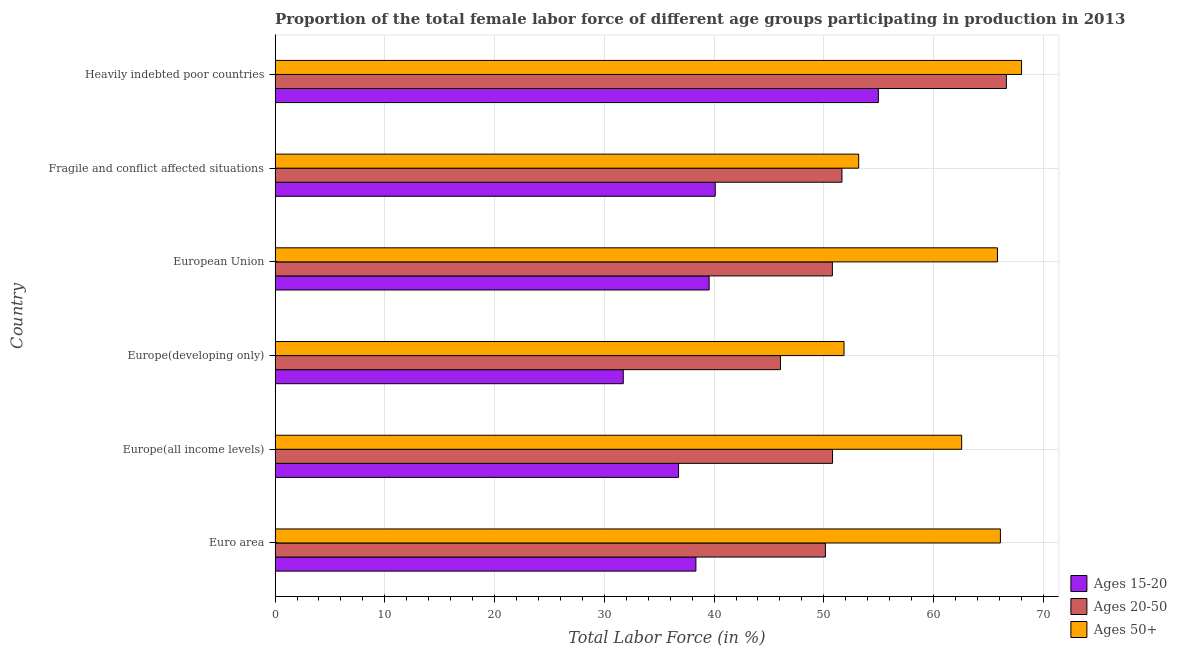Are the number of bars per tick equal to the number of legend labels?
Make the answer very short. Yes. Are the number of bars on each tick of the Y-axis equal?
Ensure brevity in your answer.  Yes. How many bars are there on the 3rd tick from the top?
Offer a very short reply. 3. How many bars are there on the 1st tick from the bottom?
Offer a very short reply. 3. What is the label of the 4th group of bars from the top?
Make the answer very short. Europe(developing only). What is the percentage of female labor force above age 50 in Euro area?
Keep it short and to the point. 66.09. Across all countries, what is the maximum percentage of female labor force above age 50?
Offer a very short reply. 68.02. Across all countries, what is the minimum percentage of female labor force within the age group 15-20?
Offer a very short reply. 31.73. In which country was the percentage of female labor force within the age group 15-20 maximum?
Ensure brevity in your answer.  Heavily indebted poor countries. In which country was the percentage of female labor force within the age group 20-50 minimum?
Make the answer very short. Europe(developing only). What is the total percentage of female labor force within the age group 15-20 in the graph?
Provide a succinct answer. 241.46. What is the difference between the percentage of female labor force within the age group 20-50 in European Union and that in Fragile and conflict affected situations?
Ensure brevity in your answer.  -0.87. What is the difference between the percentage of female labor force within the age group 15-20 in Europe(developing only) and the percentage of female labor force above age 50 in European Union?
Make the answer very short. -34.1. What is the average percentage of female labor force above age 50 per country?
Offer a very short reply. 61.25. What is the difference between the percentage of female labor force within the age group 15-20 and percentage of female labor force above age 50 in Euro area?
Your response must be concise. -27.74. What is the ratio of the percentage of female labor force within the age group 15-20 in Europe(developing only) to that in European Union?
Your answer should be compact. 0.8. What is the difference between the highest and the second highest percentage of female labor force within the age group 15-20?
Your answer should be compact. 14.86. What is the difference between the highest and the lowest percentage of female labor force within the age group 15-20?
Provide a short and direct response. 23.24. What does the 3rd bar from the top in Heavily indebted poor countries represents?
Give a very brief answer. Ages 15-20. What does the 2nd bar from the bottom in European Union represents?
Keep it short and to the point. Ages 20-50. Are all the bars in the graph horizontal?
Offer a very short reply. Yes. What is the difference between two consecutive major ticks on the X-axis?
Keep it short and to the point. 10. Are the values on the major ticks of X-axis written in scientific E-notation?
Make the answer very short. No. Does the graph contain any zero values?
Keep it short and to the point. No. Does the graph contain grids?
Make the answer very short. Yes. How many legend labels are there?
Offer a terse response. 3. How are the legend labels stacked?
Make the answer very short. Vertical. What is the title of the graph?
Your answer should be very brief. Proportion of the total female labor force of different age groups participating in production in 2013. Does "Taxes on income" appear as one of the legend labels in the graph?
Make the answer very short. No. What is the label or title of the X-axis?
Provide a short and direct response. Total Labor Force (in %). What is the Total Labor Force (in %) of Ages 15-20 in Euro area?
Provide a short and direct response. 38.34. What is the Total Labor Force (in %) of Ages 20-50 in Euro area?
Offer a terse response. 50.14. What is the Total Labor Force (in %) in Ages 50+ in Euro area?
Make the answer very short. 66.09. What is the Total Labor Force (in %) of Ages 15-20 in Europe(all income levels)?
Your answer should be compact. 36.76. What is the Total Labor Force (in %) of Ages 20-50 in Europe(all income levels)?
Offer a terse response. 50.79. What is the Total Labor Force (in %) in Ages 50+ in Europe(all income levels)?
Give a very brief answer. 62.56. What is the Total Labor Force (in %) of Ages 15-20 in Europe(developing only)?
Give a very brief answer. 31.73. What is the Total Labor Force (in %) of Ages 20-50 in Europe(developing only)?
Make the answer very short. 46.05. What is the Total Labor Force (in %) in Ages 50+ in Europe(developing only)?
Your response must be concise. 51.84. What is the Total Labor Force (in %) in Ages 15-20 in European Union?
Offer a terse response. 39.55. What is the Total Labor Force (in %) in Ages 20-50 in European Union?
Ensure brevity in your answer.  50.78. What is the Total Labor Force (in %) in Ages 50+ in European Union?
Offer a terse response. 65.82. What is the Total Labor Force (in %) in Ages 15-20 in Fragile and conflict affected situations?
Give a very brief answer. 40.11. What is the Total Labor Force (in %) in Ages 20-50 in Fragile and conflict affected situations?
Your response must be concise. 51.65. What is the Total Labor Force (in %) in Ages 50+ in Fragile and conflict affected situations?
Offer a terse response. 53.18. What is the Total Labor Force (in %) of Ages 15-20 in Heavily indebted poor countries?
Provide a short and direct response. 54.97. What is the Total Labor Force (in %) in Ages 20-50 in Heavily indebted poor countries?
Provide a succinct answer. 66.63. What is the Total Labor Force (in %) of Ages 50+ in Heavily indebted poor countries?
Offer a terse response. 68.02. Across all countries, what is the maximum Total Labor Force (in %) of Ages 15-20?
Give a very brief answer. 54.97. Across all countries, what is the maximum Total Labor Force (in %) of Ages 20-50?
Give a very brief answer. 66.63. Across all countries, what is the maximum Total Labor Force (in %) of Ages 50+?
Your answer should be compact. 68.02. Across all countries, what is the minimum Total Labor Force (in %) in Ages 15-20?
Provide a short and direct response. 31.73. Across all countries, what is the minimum Total Labor Force (in %) in Ages 20-50?
Your answer should be very brief. 46.05. Across all countries, what is the minimum Total Labor Force (in %) in Ages 50+?
Offer a terse response. 51.84. What is the total Total Labor Force (in %) in Ages 15-20 in the graph?
Ensure brevity in your answer.  241.46. What is the total Total Labor Force (in %) of Ages 20-50 in the graph?
Your answer should be compact. 316.05. What is the total Total Labor Force (in %) of Ages 50+ in the graph?
Give a very brief answer. 367.5. What is the difference between the Total Labor Force (in %) in Ages 15-20 in Euro area and that in Europe(all income levels)?
Make the answer very short. 1.58. What is the difference between the Total Labor Force (in %) of Ages 20-50 in Euro area and that in Europe(all income levels)?
Your answer should be very brief. -0.65. What is the difference between the Total Labor Force (in %) of Ages 50+ in Euro area and that in Europe(all income levels)?
Your answer should be very brief. 3.53. What is the difference between the Total Labor Force (in %) of Ages 15-20 in Euro area and that in Europe(developing only)?
Offer a terse response. 6.62. What is the difference between the Total Labor Force (in %) of Ages 20-50 in Euro area and that in Europe(developing only)?
Give a very brief answer. 4.1. What is the difference between the Total Labor Force (in %) in Ages 50+ in Euro area and that in Europe(developing only)?
Your answer should be compact. 14.25. What is the difference between the Total Labor Force (in %) in Ages 15-20 in Euro area and that in European Union?
Provide a short and direct response. -1.21. What is the difference between the Total Labor Force (in %) in Ages 20-50 in Euro area and that in European Union?
Your response must be concise. -0.64. What is the difference between the Total Labor Force (in %) of Ages 50+ in Euro area and that in European Union?
Offer a terse response. 0.27. What is the difference between the Total Labor Force (in %) of Ages 15-20 in Euro area and that in Fragile and conflict affected situations?
Provide a succinct answer. -1.76. What is the difference between the Total Labor Force (in %) in Ages 20-50 in Euro area and that in Fragile and conflict affected situations?
Keep it short and to the point. -1.51. What is the difference between the Total Labor Force (in %) in Ages 50+ in Euro area and that in Fragile and conflict affected situations?
Offer a very short reply. 12.91. What is the difference between the Total Labor Force (in %) in Ages 15-20 in Euro area and that in Heavily indebted poor countries?
Your response must be concise. -16.62. What is the difference between the Total Labor Force (in %) of Ages 20-50 in Euro area and that in Heavily indebted poor countries?
Ensure brevity in your answer.  -16.49. What is the difference between the Total Labor Force (in %) of Ages 50+ in Euro area and that in Heavily indebted poor countries?
Ensure brevity in your answer.  -1.93. What is the difference between the Total Labor Force (in %) of Ages 15-20 in Europe(all income levels) and that in Europe(developing only)?
Your answer should be compact. 5.04. What is the difference between the Total Labor Force (in %) in Ages 20-50 in Europe(all income levels) and that in Europe(developing only)?
Ensure brevity in your answer.  4.75. What is the difference between the Total Labor Force (in %) in Ages 50+ in Europe(all income levels) and that in Europe(developing only)?
Ensure brevity in your answer.  10.72. What is the difference between the Total Labor Force (in %) in Ages 15-20 in Europe(all income levels) and that in European Union?
Provide a succinct answer. -2.79. What is the difference between the Total Labor Force (in %) of Ages 20-50 in Europe(all income levels) and that in European Union?
Offer a very short reply. 0.01. What is the difference between the Total Labor Force (in %) of Ages 50+ in Europe(all income levels) and that in European Union?
Ensure brevity in your answer.  -3.26. What is the difference between the Total Labor Force (in %) of Ages 15-20 in Europe(all income levels) and that in Fragile and conflict affected situations?
Make the answer very short. -3.34. What is the difference between the Total Labor Force (in %) in Ages 20-50 in Europe(all income levels) and that in Fragile and conflict affected situations?
Your response must be concise. -0.86. What is the difference between the Total Labor Force (in %) in Ages 50+ in Europe(all income levels) and that in Fragile and conflict affected situations?
Your answer should be very brief. 9.38. What is the difference between the Total Labor Force (in %) of Ages 15-20 in Europe(all income levels) and that in Heavily indebted poor countries?
Provide a succinct answer. -18.21. What is the difference between the Total Labor Force (in %) of Ages 20-50 in Europe(all income levels) and that in Heavily indebted poor countries?
Provide a short and direct response. -15.84. What is the difference between the Total Labor Force (in %) in Ages 50+ in Europe(all income levels) and that in Heavily indebted poor countries?
Make the answer very short. -5.46. What is the difference between the Total Labor Force (in %) of Ages 15-20 in Europe(developing only) and that in European Union?
Offer a very short reply. -7.82. What is the difference between the Total Labor Force (in %) of Ages 20-50 in Europe(developing only) and that in European Union?
Offer a very short reply. -4.73. What is the difference between the Total Labor Force (in %) in Ages 50+ in Europe(developing only) and that in European Union?
Keep it short and to the point. -13.98. What is the difference between the Total Labor Force (in %) in Ages 15-20 in Europe(developing only) and that in Fragile and conflict affected situations?
Keep it short and to the point. -8.38. What is the difference between the Total Labor Force (in %) of Ages 20-50 in Europe(developing only) and that in Fragile and conflict affected situations?
Ensure brevity in your answer.  -5.61. What is the difference between the Total Labor Force (in %) in Ages 50+ in Europe(developing only) and that in Fragile and conflict affected situations?
Give a very brief answer. -1.33. What is the difference between the Total Labor Force (in %) in Ages 15-20 in Europe(developing only) and that in Heavily indebted poor countries?
Offer a terse response. -23.24. What is the difference between the Total Labor Force (in %) in Ages 20-50 in Europe(developing only) and that in Heavily indebted poor countries?
Give a very brief answer. -20.59. What is the difference between the Total Labor Force (in %) of Ages 50+ in Europe(developing only) and that in Heavily indebted poor countries?
Keep it short and to the point. -16.18. What is the difference between the Total Labor Force (in %) in Ages 15-20 in European Union and that in Fragile and conflict affected situations?
Provide a short and direct response. -0.56. What is the difference between the Total Labor Force (in %) in Ages 20-50 in European Union and that in Fragile and conflict affected situations?
Your response must be concise. -0.87. What is the difference between the Total Labor Force (in %) in Ages 50+ in European Union and that in Fragile and conflict affected situations?
Keep it short and to the point. 12.64. What is the difference between the Total Labor Force (in %) in Ages 15-20 in European Union and that in Heavily indebted poor countries?
Offer a very short reply. -15.42. What is the difference between the Total Labor Force (in %) of Ages 20-50 in European Union and that in Heavily indebted poor countries?
Ensure brevity in your answer.  -15.86. What is the difference between the Total Labor Force (in %) in Ages 50+ in European Union and that in Heavily indebted poor countries?
Ensure brevity in your answer.  -2.2. What is the difference between the Total Labor Force (in %) of Ages 15-20 in Fragile and conflict affected situations and that in Heavily indebted poor countries?
Offer a terse response. -14.86. What is the difference between the Total Labor Force (in %) in Ages 20-50 in Fragile and conflict affected situations and that in Heavily indebted poor countries?
Offer a terse response. -14.98. What is the difference between the Total Labor Force (in %) in Ages 50+ in Fragile and conflict affected situations and that in Heavily indebted poor countries?
Offer a terse response. -14.84. What is the difference between the Total Labor Force (in %) of Ages 15-20 in Euro area and the Total Labor Force (in %) of Ages 20-50 in Europe(all income levels)?
Your answer should be compact. -12.45. What is the difference between the Total Labor Force (in %) of Ages 15-20 in Euro area and the Total Labor Force (in %) of Ages 50+ in Europe(all income levels)?
Offer a very short reply. -24.22. What is the difference between the Total Labor Force (in %) of Ages 20-50 in Euro area and the Total Labor Force (in %) of Ages 50+ in Europe(all income levels)?
Give a very brief answer. -12.42. What is the difference between the Total Labor Force (in %) of Ages 15-20 in Euro area and the Total Labor Force (in %) of Ages 20-50 in Europe(developing only)?
Give a very brief answer. -7.7. What is the difference between the Total Labor Force (in %) of Ages 15-20 in Euro area and the Total Labor Force (in %) of Ages 50+ in Europe(developing only)?
Keep it short and to the point. -13.5. What is the difference between the Total Labor Force (in %) in Ages 20-50 in Euro area and the Total Labor Force (in %) in Ages 50+ in Europe(developing only)?
Give a very brief answer. -1.7. What is the difference between the Total Labor Force (in %) in Ages 15-20 in Euro area and the Total Labor Force (in %) in Ages 20-50 in European Union?
Keep it short and to the point. -12.43. What is the difference between the Total Labor Force (in %) of Ages 15-20 in Euro area and the Total Labor Force (in %) of Ages 50+ in European Union?
Offer a terse response. -27.48. What is the difference between the Total Labor Force (in %) of Ages 20-50 in Euro area and the Total Labor Force (in %) of Ages 50+ in European Union?
Give a very brief answer. -15.68. What is the difference between the Total Labor Force (in %) in Ages 15-20 in Euro area and the Total Labor Force (in %) in Ages 20-50 in Fragile and conflict affected situations?
Keep it short and to the point. -13.31. What is the difference between the Total Labor Force (in %) of Ages 15-20 in Euro area and the Total Labor Force (in %) of Ages 50+ in Fragile and conflict affected situations?
Your answer should be very brief. -14.83. What is the difference between the Total Labor Force (in %) of Ages 20-50 in Euro area and the Total Labor Force (in %) of Ages 50+ in Fragile and conflict affected situations?
Ensure brevity in your answer.  -3.03. What is the difference between the Total Labor Force (in %) of Ages 15-20 in Euro area and the Total Labor Force (in %) of Ages 20-50 in Heavily indebted poor countries?
Provide a short and direct response. -28.29. What is the difference between the Total Labor Force (in %) in Ages 15-20 in Euro area and the Total Labor Force (in %) in Ages 50+ in Heavily indebted poor countries?
Keep it short and to the point. -29.67. What is the difference between the Total Labor Force (in %) in Ages 20-50 in Euro area and the Total Labor Force (in %) in Ages 50+ in Heavily indebted poor countries?
Give a very brief answer. -17.87. What is the difference between the Total Labor Force (in %) of Ages 15-20 in Europe(all income levels) and the Total Labor Force (in %) of Ages 20-50 in Europe(developing only)?
Offer a terse response. -9.28. What is the difference between the Total Labor Force (in %) in Ages 15-20 in Europe(all income levels) and the Total Labor Force (in %) in Ages 50+ in Europe(developing only)?
Keep it short and to the point. -15.08. What is the difference between the Total Labor Force (in %) of Ages 20-50 in Europe(all income levels) and the Total Labor Force (in %) of Ages 50+ in Europe(developing only)?
Offer a terse response. -1.05. What is the difference between the Total Labor Force (in %) in Ages 15-20 in Europe(all income levels) and the Total Labor Force (in %) in Ages 20-50 in European Union?
Offer a terse response. -14.02. What is the difference between the Total Labor Force (in %) of Ages 15-20 in Europe(all income levels) and the Total Labor Force (in %) of Ages 50+ in European Union?
Offer a terse response. -29.06. What is the difference between the Total Labor Force (in %) of Ages 20-50 in Europe(all income levels) and the Total Labor Force (in %) of Ages 50+ in European Union?
Ensure brevity in your answer.  -15.03. What is the difference between the Total Labor Force (in %) in Ages 15-20 in Europe(all income levels) and the Total Labor Force (in %) in Ages 20-50 in Fragile and conflict affected situations?
Your answer should be compact. -14.89. What is the difference between the Total Labor Force (in %) in Ages 15-20 in Europe(all income levels) and the Total Labor Force (in %) in Ages 50+ in Fragile and conflict affected situations?
Provide a succinct answer. -16.41. What is the difference between the Total Labor Force (in %) of Ages 20-50 in Europe(all income levels) and the Total Labor Force (in %) of Ages 50+ in Fragile and conflict affected situations?
Your answer should be very brief. -2.38. What is the difference between the Total Labor Force (in %) in Ages 15-20 in Europe(all income levels) and the Total Labor Force (in %) in Ages 20-50 in Heavily indebted poor countries?
Make the answer very short. -29.87. What is the difference between the Total Labor Force (in %) of Ages 15-20 in Europe(all income levels) and the Total Labor Force (in %) of Ages 50+ in Heavily indebted poor countries?
Ensure brevity in your answer.  -31.25. What is the difference between the Total Labor Force (in %) of Ages 20-50 in Europe(all income levels) and the Total Labor Force (in %) of Ages 50+ in Heavily indebted poor countries?
Give a very brief answer. -17.22. What is the difference between the Total Labor Force (in %) in Ages 15-20 in Europe(developing only) and the Total Labor Force (in %) in Ages 20-50 in European Union?
Keep it short and to the point. -19.05. What is the difference between the Total Labor Force (in %) of Ages 15-20 in Europe(developing only) and the Total Labor Force (in %) of Ages 50+ in European Union?
Provide a succinct answer. -34.1. What is the difference between the Total Labor Force (in %) in Ages 20-50 in Europe(developing only) and the Total Labor Force (in %) in Ages 50+ in European Union?
Your answer should be very brief. -19.77. What is the difference between the Total Labor Force (in %) of Ages 15-20 in Europe(developing only) and the Total Labor Force (in %) of Ages 20-50 in Fragile and conflict affected situations?
Give a very brief answer. -19.93. What is the difference between the Total Labor Force (in %) of Ages 15-20 in Europe(developing only) and the Total Labor Force (in %) of Ages 50+ in Fragile and conflict affected situations?
Your answer should be compact. -21.45. What is the difference between the Total Labor Force (in %) of Ages 20-50 in Europe(developing only) and the Total Labor Force (in %) of Ages 50+ in Fragile and conflict affected situations?
Your answer should be very brief. -7.13. What is the difference between the Total Labor Force (in %) of Ages 15-20 in Europe(developing only) and the Total Labor Force (in %) of Ages 20-50 in Heavily indebted poor countries?
Make the answer very short. -34.91. What is the difference between the Total Labor Force (in %) in Ages 15-20 in Europe(developing only) and the Total Labor Force (in %) in Ages 50+ in Heavily indebted poor countries?
Your answer should be very brief. -36.29. What is the difference between the Total Labor Force (in %) of Ages 20-50 in Europe(developing only) and the Total Labor Force (in %) of Ages 50+ in Heavily indebted poor countries?
Offer a terse response. -21.97. What is the difference between the Total Labor Force (in %) of Ages 15-20 in European Union and the Total Labor Force (in %) of Ages 20-50 in Fragile and conflict affected situations?
Provide a short and direct response. -12.1. What is the difference between the Total Labor Force (in %) in Ages 15-20 in European Union and the Total Labor Force (in %) in Ages 50+ in Fragile and conflict affected situations?
Offer a very short reply. -13.63. What is the difference between the Total Labor Force (in %) in Ages 20-50 in European Union and the Total Labor Force (in %) in Ages 50+ in Fragile and conflict affected situations?
Your answer should be compact. -2.4. What is the difference between the Total Labor Force (in %) of Ages 15-20 in European Union and the Total Labor Force (in %) of Ages 20-50 in Heavily indebted poor countries?
Provide a succinct answer. -27.09. What is the difference between the Total Labor Force (in %) in Ages 15-20 in European Union and the Total Labor Force (in %) in Ages 50+ in Heavily indebted poor countries?
Keep it short and to the point. -28.47. What is the difference between the Total Labor Force (in %) of Ages 20-50 in European Union and the Total Labor Force (in %) of Ages 50+ in Heavily indebted poor countries?
Offer a terse response. -17.24. What is the difference between the Total Labor Force (in %) of Ages 15-20 in Fragile and conflict affected situations and the Total Labor Force (in %) of Ages 20-50 in Heavily indebted poor countries?
Make the answer very short. -26.53. What is the difference between the Total Labor Force (in %) in Ages 15-20 in Fragile and conflict affected situations and the Total Labor Force (in %) in Ages 50+ in Heavily indebted poor countries?
Your answer should be very brief. -27.91. What is the difference between the Total Labor Force (in %) in Ages 20-50 in Fragile and conflict affected situations and the Total Labor Force (in %) in Ages 50+ in Heavily indebted poor countries?
Keep it short and to the point. -16.36. What is the average Total Labor Force (in %) of Ages 15-20 per country?
Provide a short and direct response. 40.24. What is the average Total Labor Force (in %) in Ages 20-50 per country?
Provide a short and direct response. 52.68. What is the average Total Labor Force (in %) in Ages 50+ per country?
Your answer should be compact. 61.25. What is the difference between the Total Labor Force (in %) of Ages 15-20 and Total Labor Force (in %) of Ages 20-50 in Euro area?
Offer a very short reply. -11.8. What is the difference between the Total Labor Force (in %) of Ages 15-20 and Total Labor Force (in %) of Ages 50+ in Euro area?
Your answer should be compact. -27.74. What is the difference between the Total Labor Force (in %) of Ages 20-50 and Total Labor Force (in %) of Ages 50+ in Euro area?
Offer a very short reply. -15.94. What is the difference between the Total Labor Force (in %) of Ages 15-20 and Total Labor Force (in %) of Ages 20-50 in Europe(all income levels)?
Keep it short and to the point. -14.03. What is the difference between the Total Labor Force (in %) in Ages 15-20 and Total Labor Force (in %) in Ages 50+ in Europe(all income levels)?
Your answer should be very brief. -25.8. What is the difference between the Total Labor Force (in %) in Ages 20-50 and Total Labor Force (in %) in Ages 50+ in Europe(all income levels)?
Provide a short and direct response. -11.77. What is the difference between the Total Labor Force (in %) of Ages 15-20 and Total Labor Force (in %) of Ages 20-50 in Europe(developing only)?
Make the answer very short. -14.32. What is the difference between the Total Labor Force (in %) of Ages 15-20 and Total Labor Force (in %) of Ages 50+ in Europe(developing only)?
Your answer should be compact. -20.12. What is the difference between the Total Labor Force (in %) of Ages 20-50 and Total Labor Force (in %) of Ages 50+ in Europe(developing only)?
Ensure brevity in your answer.  -5.79. What is the difference between the Total Labor Force (in %) of Ages 15-20 and Total Labor Force (in %) of Ages 20-50 in European Union?
Your answer should be compact. -11.23. What is the difference between the Total Labor Force (in %) of Ages 15-20 and Total Labor Force (in %) of Ages 50+ in European Union?
Keep it short and to the point. -26.27. What is the difference between the Total Labor Force (in %) of Ages 20-50 and Total Labor Force (in %) of Ages 50+ in European Union?
Provide a short and direct response. -15.04. What is the difference between the Total Labor Force (in %) of Ages 15-20 and Total Labor Force (in %) of Ages 20-50 in Fragile and conflict affected situations?
Your response must be concise. -11.55. What is the difference between the Total Labor Force (in %) in Ages 15-20 and Total Labor Force (in %) in Ages 50+ in Fragile and conflict affected situations?
Provide a short and direct response. -13.07. What is the difference between the Total Labor Force (in %) in Ages 20-50 and Total Labor Force (in %) in Ages 50+ in Fragile and conflict affected situations?
Provide a short and direct response. -1.52. What is the difference between the Total Labor Force (in %) of Ages 15-20 and Total Labor Force (in %) of Ages 20-50 in Heavily indebted poor countries?
Your answer should be compact. -11.67. What is the difference between the Total Labor Force (in %) of Ages 15-20 and Total Labor Force (in %) of Ages 50+ in Heavily indebted poor countries?
Make the answer very short. -13.05. What is the difference between the Total Labor Force (in %) of Ages 20-50 and Total Labor Force (in %) of Ages 50+ in Heavily indebted poor countries?
Your response must be concise. -1.38. What is the ratio of the Total Labor Force (in %) in Ages 15-20 in Euro area to that in Europe(all income levels)?
Your answer should be very brief. 1.04. What is the ratio of the Total Labor Force (in %) of Ages 20-50 in Euro area to that in Europe(all income levels)?
Keep it short and to the point. 0.99. What is the ratio of the Total Labor Force (in %) of Ages 50+ in Euro area to that in Europe(all income levels)?
Provide a short and direct response. 1.06. What is the ratio of the Total Labor Force (in %) in Ages 15-20 in Euro area to that in Europe(developing only)?
Offer a very short reply. 1.21. What is the ratio of the Total Labor Force (in %) in Ages 20-50 in Euro area to that in Europe(developing only)?
Provide a succinct answer. 1.09. What is the ratio of the Total Labor Force (in %) of Ages 50+ in Euro area to that in Europe(developing only)?
Ensure brevity in your answer.  1.27. What is the ratio of the Total Labor Force (in %) in Ages 15-20 in Euro area to that in European Union?
Offer a very short reply. 0.97. What is the ratio of the Total Labor Force (in %) of Ages 20-50 in Euro area to that in European Union?
Make the answer very short. 0.99. What is the ratio of the Total Labor Force (in %) of Ages 15-20 in Euro area to that in Fragile and conflict affected situations?
Your response must be concise. 0.96. What is the ratio of the Total Labor Force (in %) of Ages 20-50 in Euro area to that in Fragile and conflict affected situations?
Ensure brevity in your answer.  0.97. What is the ratio of the Total Labor Force (in %) in Ages 50+ in Euro area to that in Fragile and conflict affected situations?
Ensure brevity in your answer.  1.24. What is the ratio of the Total Labor Force (in %) in Ages 15-20 in Euro area to that in Heavily indebted poor countries?
Your answer should be compact. 0.7. What is the ratio of the Total Labor Force (in %) in Ages 20-50 in Euro area to that in Heavily indebted poor countries?
Offer a terse response. 0.75. What is the ratio of the Total Labor Force (in %) of Ages 50+ in Euro area to that in Heavily indebted poor countries?
Your answer should be very brief. 0.97. What is the ratio of the Total Labor Force (in %) in Ages 15-20 in Europe(all income levels) to that in Europe(developing only)?
Give a very brief answer. 1.16. What is the ratio of the Total Labor Force (in %) in Ages 20-50 in Europe(all income levels) to that in Europe(developing only)?
Give a very brief answer. 1.1. What is the ratio of the Total Labor Force (in %) in Ages 50+ in Europe(all income levels) to that in Europe(developing only)?
Make the answer very short. 1.21. What is the ratio of the Total Labor Force (in %) in Ages 15-20 in Europe(all income levels) to that in European Union?
Your answer should be very brief. 0.93. What is the ratio of the Total Labor Force (in %) of Ages 20-50 in Europe(all income levels) to that in European Union?
Offer a terse response. 1. What is the ratio of the Total Labor Force (in %) in Ages 50+ in Europe(all income levels) to that in European Union?
Your answer should be very brief. 0.95. What is the ratio of the Total Labor Force (in %) of Ages 15-20 in Europe(all income levels) to that in Fragile and conflict affected situations?
Provide a short and direct response. 0.92. What is the ratio of the Total Labor Force (in %) of Ages 20-50 in Europe(all income levels) to that in Fragile and conflict affected situations?
Offer a very short reply. 0.98. What is the ratio of the Total Labor Force (in %) in Ages 50+ in Europe(all income levels) to that in Fragile and conflict affected situations?
Make the answer very short. 1.18. What is the ratio of the Total Labor Force (in %) in Ages 15-20 in Europe(all income levels) to that in Heavily indebted poor countries?
Provide a short and direct response. 0.67. What is the ratio of the Total Labor Force (in %) in Ages 20-50 in Europe(all income levels) to that in Heavily indebted poor countries?
Give a very brief answer. 0.76. What is the ratio of the Total Labor Force (in %) in Ages 50+ in Europe(all income levels) to that in Heavily indebted poor countries?
Provide a short and direct response. 0.92. What is the ratio of the Total Labor Force (in %) of Ages 15-20 in Europe(developing only) to that in European Union?
Your answer should be compact. 0.8. What is the ratio of the Total Labor Force (in %) of Ages 20-50 in Europe(developing only) to that in European Union?
Offer a very short reply. 0.91. What is the ratio of the Total Labor Force (in %) in Ages 50+ in Europe(developing only) to that in European Union?
Give a very brief answer. 0.79. What is the ratio of the Total Labor Force (in %) in Ages 15-20 in Europe(developing only) to that in Fragile and conflict affected situations?
Provide a succinct answer. 0.79. What is the ratio of the Total Labor Force (in %) in Ages 20-50 in Europe(developing only) to that in Fragile and conflict affected situations?
Keep it short and to the point. 0.89. What is the ratio of the Total Labor Force (in %) of Ages 50+ in Europe(developing only) to that in Fragile and conflict affected situations?
Your answer should be compact. 0.97. What is the ratio of the Total Labor Force (in %) in Ages 15-20 in Europe(developing only) to that in Heavily indebted poor countries?
Offer a very short reply. 0.58. What is the ratio of the Total Labor Force (in %) in Ages 20-50 in Europe(developing only) to that in Heavily indebted poor countries?
Your response must be concise. 0.69. What is the ratio of the Total Labor Force (in %) of Ages 50+ in Europe(developing only) to that in Heavily indebted poor countries?
Offer a terse response. 0.76. What is the ratio of the Total Labor Force (in %) in Ages 15-20 in European Union to that in Fragile and conflict affected situations?
Keep it short and to the point. 0.99. What is the ratio of the Total Labor Force (in %) in Ages 20-50 in European Union to that in Fragile and conflict affected situations?
Offer a very short reply. 0.98. What is the ratio of the Total Labor Force (in %) in Ages 50+ in European Union to that in Fragile and conflict affected situations?
Make the answer very short. 1.24. What is the ratio of the Total Labor Force (in %) of Ages 15-20 in European Union to that in Heavily indebted poor countries?
Keep it short and to the point. 0.72. What is the ratio of the Total Labor Force (in %) in Ages 20-50 in European Union to that in Heavily indebted poor countries?
Make the answer very short. 0.76. What is the ratio of the Total Labor Force (in %) in Ages 15-20 in Fragile and conflict affected situations to that in Heavily indebted poor countries?
Provide a short and direct response. 0.73. What is the ratio of the Total Labor Force (in %) in Ages 20-50 in Fragile and conflict affected situations to that in Heavily indebted poor countries?
Offer a very short reply. 0.78. What is the ratio of the Total Labor Force (in %) in Ages 50+ in Fragile and conflict affected situations to that in Heavily indebted poor countries?
Make the answer very short. 0.78. What is the difference between the highest and the second highest Total Labor Force (in %) of Ages 15-20?
Provide a succinct answer. 14.86. What is the difference between the highest and the second highest Total Labor Force (in %) in Ages 20-50?
Ensure brevity in your answer.  14.98. What is the difference between the highest and the second highest Total Labor Force (in %) of Ages 50+?
Your answer should be compact. 1.93. What is the difference between the highest and the lowest Total Labor Force (in %) of Ages 15-20?
Offer a terse response. 23.24. What is the difference between the highest and the lowest Total Labor Force (in %) in Ages 20-50?
Make the answer very short. 20.59. What is the difference between the highest and the lowest Total Labor Force (in %) of Ages 50+?
Make the answer very short. 16.18. 